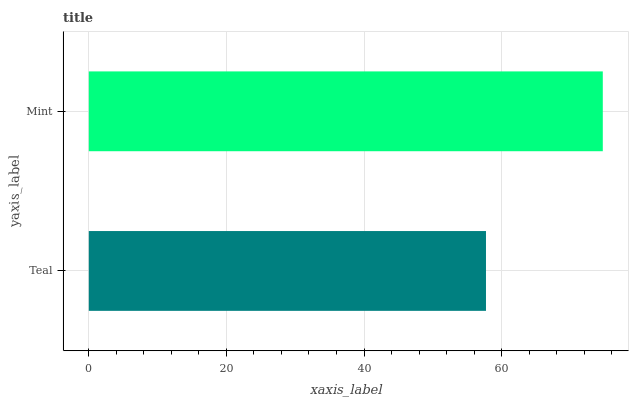Is Teal the minimum?
Answer yes or no. Yes. Is Mint the maximum?
Answer yes or no. Yes. Is Mint the minimum?
Answer yes or no. No. Is Mint greater than Teal?
Answer yes or no. Yes. Is Teal less than Mint?
Answer yes or no. Yes. Is Teal greater than Mint?
Answer yes or no. No. Is Mint less than Teal?
Answer yes or no. No. Is Mint the high median?
Answer yes or no. Yes. Is Teal the low median?
Answer yes or no. Yes. Is Teal the high median?
Answer yes or no. No. Is Mint the low median?
Answer yes or no. No. 